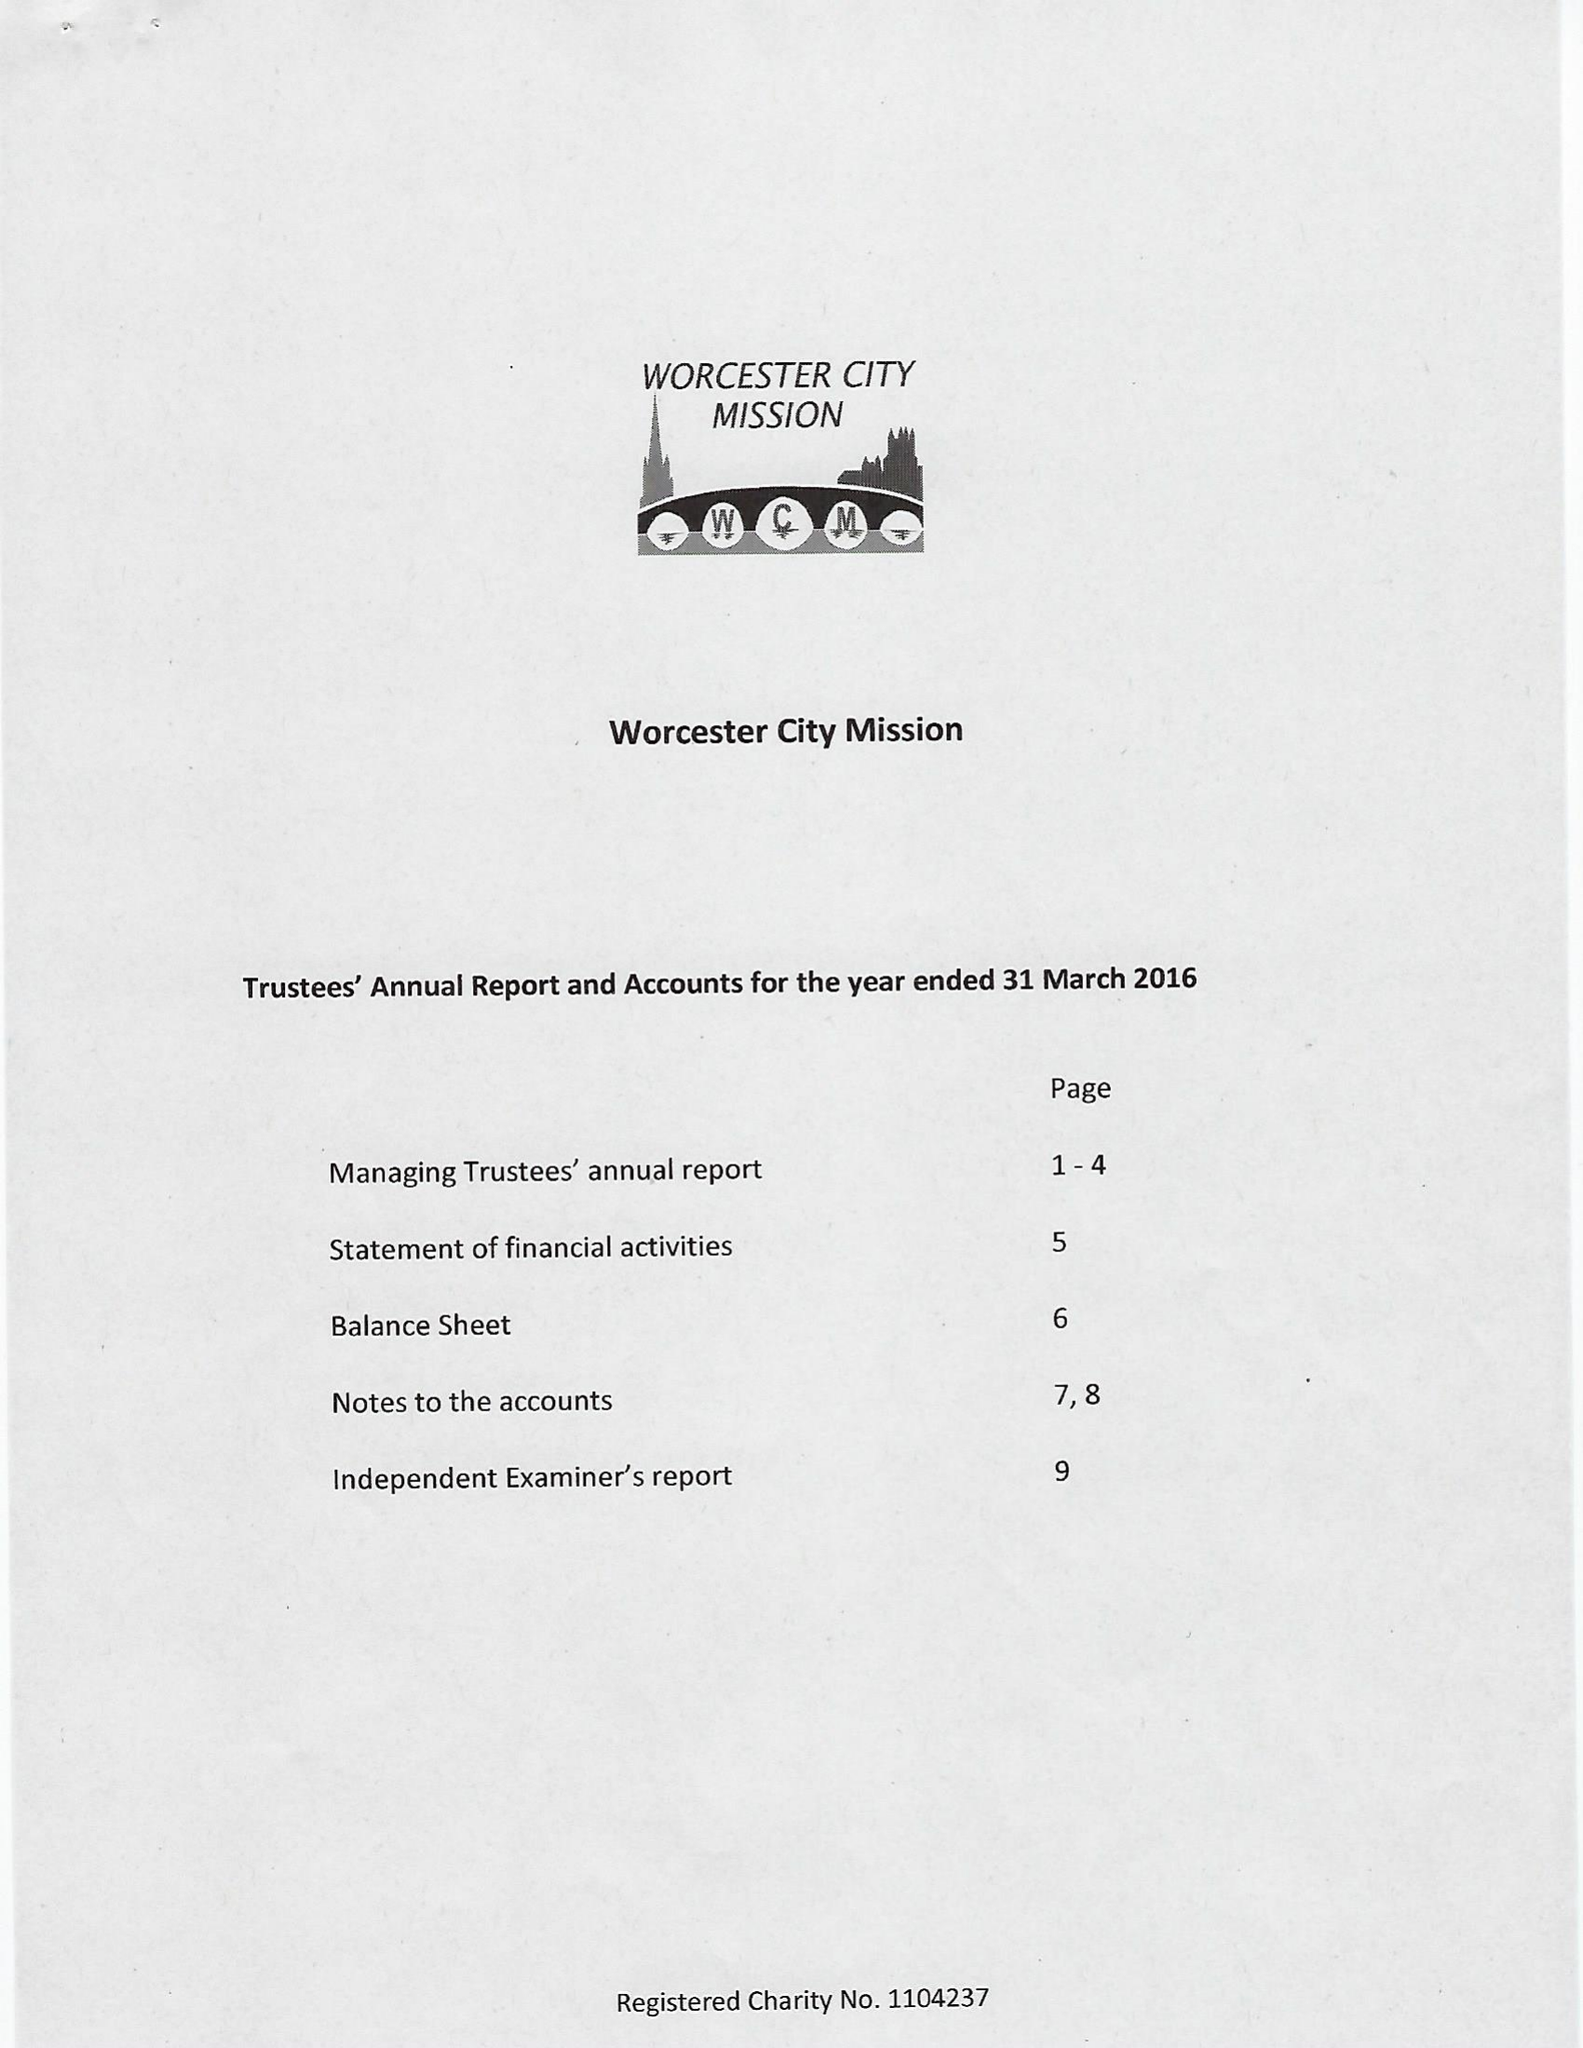What is the value for the address__post_town?
Answer the question using a single word or phrase. WORCESTER 